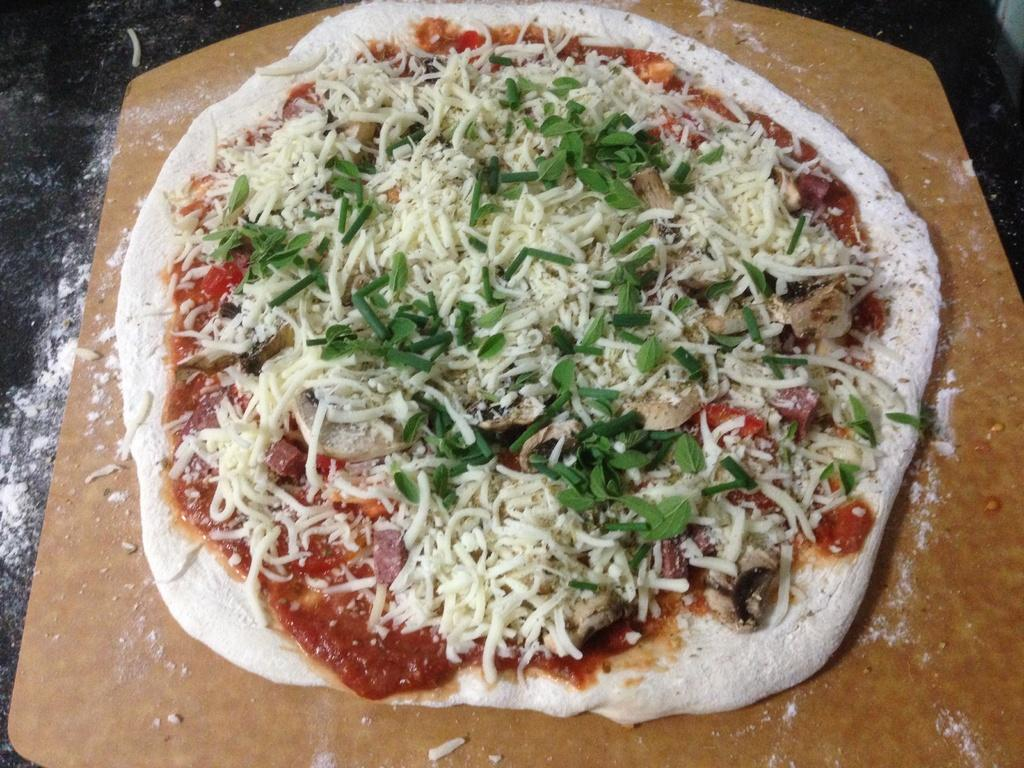What object is featured in the image that is used for holding items? There is a wooden tray in the image that is used for holding items. What type of food is on the wooden tray? The wooden tray contains pizza. What substance is present on the surface of the wooden tray? Dry powder is present on the surface of the wooden tray. What type of frame is surrounding the pizza on the wooden tray? There is no frame surrounding the pizza on the wooden tray; it is simply placed on the tray. How many crows are visible on the wooden tray in the image? There are no crows present in the image. 